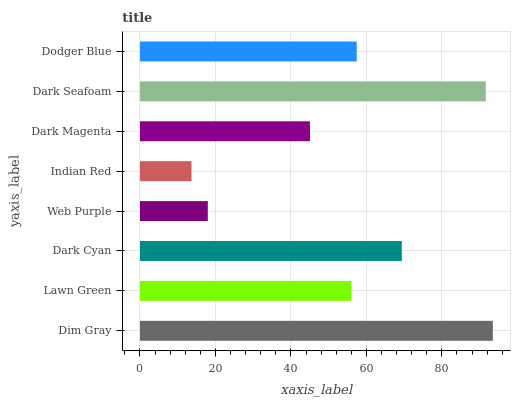Is Indian Red the minimum?
Answer yes or no. Yes. Is Dim Gray the maximum?
Answer yes or no. Yes. Is Lawn Green the minimum?
Answer yes or no. No. Is Lawn Green the maximum?
Answer yes or no. No. Is Dim Gray greater than Lawn Green?
Answer yes or no. Yes. Is Lawn Green less than Dim Gray?
Answer yes or no. Yes. Is Lawn Green greater than Dim Gray?
Answer yes or no. No. Is Dim Gray less than Lawn Green?
Answer yes or no. No. Is Dodger Blue the high median?
Answer yes or no. Yes. Is Lawn Green the low median?
Answer yes or no. Yes. Is Dark Cyan the high median?
Answer yes or no. No. Is Web Purple the low median?
Answer yes or no. No. 